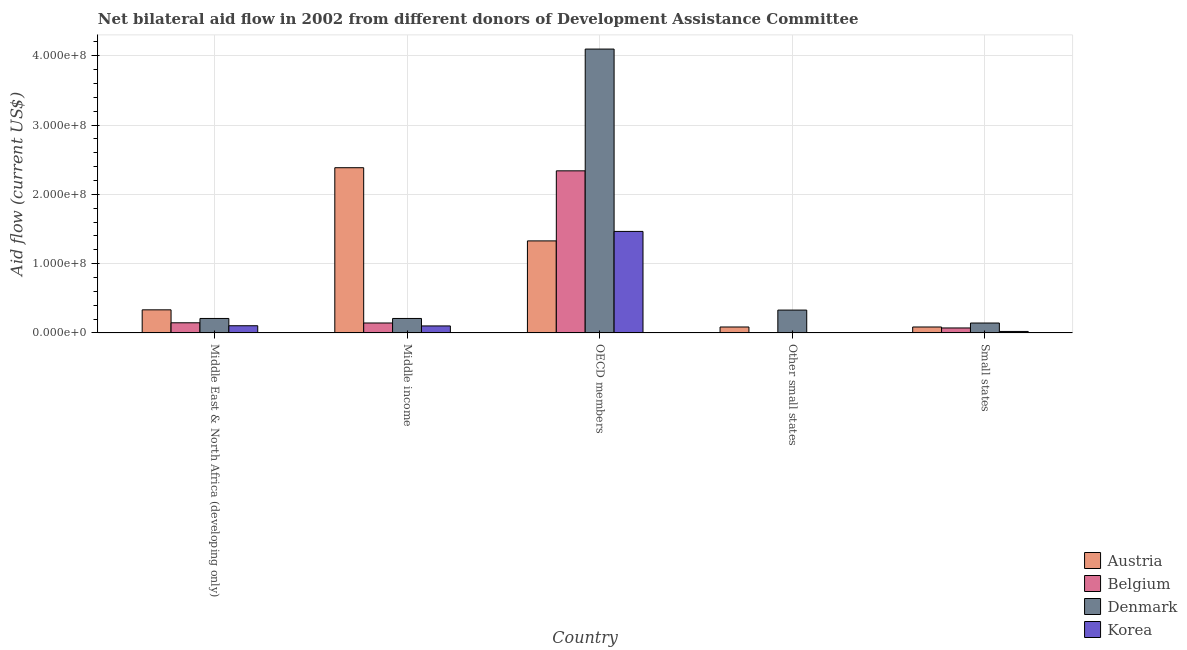How many different coloured bars are there?
Your response must be concise. 4. How many groups of bars are there?
Give a very brief answer. 5. How many bars are there on the 2nd tick from the right?
Make the answer very short. 2. What is the label of the 5th group of bars from the left?
Make the answer very short. Small states. In how many cases, is the number of bars for a given country not equal to the number of legend labels?
Ensure brevity in your answer.  1. What is the amount of aid given by austria in Middle income?
Your response must be concise. 2.38e+08. Across all countries, what is the maximum amount of aid given by austria?
Provide a short and direct response. 2.38e+08. What is the total amount of aid given by denmark in the graph?
Provide a short and direct response. 4.99e+08. What is the difference between the amount of aid given by korea in OECD members and that in Small states?
Provide a succinct answer. 1.44e+08. What is the difference between the amount of aid given by korea in OECD members and the amount of aid given by denmark in Other small states?
Provide a short and direct response. 1.14e+08. What is the average amount of aid given by denmark per country?
Offer a very short reply. 9.98e+07. What is the difference between the amount of aid given by korea and amount of aid given by belgium in Middle East & North Africa (developing only)?
Offer a very short reply. -4.26e+06. What is the ratio of the amount of aid given by denmark in Middle income to that in OECD members?
Ensure brevity in your answer.  0.05. Is the difference between the amount of aid given by denmark in Middle East & North Africa (developing only) and OECD members greater than the difference between the amount of aid given by korea in Middle East & North Africa (developing only) and OECD members?
Offer a very short reply. No. What is the difference between the highest and the second highest amount of aid given by austria?
Your answer should be very brief. 1.06e+08. What is the difference between the highest and the lowest amount of aid given by korea?
Your answer should be very brief. 1.47e+08. Is it the case that in every country, the sum of the amount of aid given by austria and amount of aid given by belgium is greater than the amount of aid given by denmark?
Provide a short and direct response. No. Are all the bars in the graph horizontal?
Keep it short and to the point. No. Does the graph contain grids?
Offer a very short reply. Yes. How are the legend labels stacked?
Ensure brevity in your answer.  Vertical. What is the title of the graph?
Your answer should be compact. Net bilateral aid flow in 2002 from different donors of Development Assistance Committee. What is the label or title of the Y-axis?
Ensure brevity in your answer.  Aid flow (current US$). What is the Aid flow (current US$) in Austria in Middle East & North Africa (developing only)?
Provide a succinct answer. 3.34e+07. What is the Aid flow (current US$) of Belgium in Middle East & North Africa (developing only)?
Provide a succinct answer. 1.46e+07. What is the Aid flow (current US$) in Denmark in Middle East & North Africa (developing only)?
Provide a short and direct response. 2.09e+07. What is the Aid flow (current US$) of Korea in Middle East & North Africa (developing only)?
Your response must be concise. 1.04e+07. What is the Aid flow (current US$) of Austria in Middle income?
Make the answer very short. 2.38e+08. What is the Aid flow (current US$) in Belgium in Middle income?
Provide a short and direct response. 1.44e+07. What is the Aid flow (current US$) of Denmark in Middle income?
Offer a very short reply. 2.09e+07. What is the Aid flow (current US$) of Korea in Middle income?
Provide a short and direct response. 1.01e+07. What is the Aid flow (current US$) of Austria in OECD members?
Make the answer very short. 1.33e+08. What is the Aid flow (current US$) of Belgium in OECD members?
Keep it short and to the point. 2.34e+08. What is the Aid flow (current US$) of Denmark in OECD members?
Keep it short and to the point. 4.10e+08. What is the Aid flow (current US$) in Korea in OECD members?
Provide a short and direct response. 1.47e+08. What is the Aid flow (current US$) in Austria in Other small states?
Your response must be concise. 8.59e+06. What is the Aid flow (current US$) of Denmark in Other small states?
Provide a short and direct response. 3.30e+07. What is the Aid flow (current US$) of Korea in Other small states?
Give a very brief answer. 0. What is the Aid flow (current US$) in Austria in Small states?
Your answer should be very brief. 8.59e+06. What is the Aid flow (current US$) in Belgium in Small states?
Offer a very short reply. 7.19e+06. What is the Aid flow (current US$) of Denmark in Small states?
Provide a succinct answer. 1.43e+07. What is the Aid flow (current US$) in Korea in Small states?
Keep it short and to the point. 2.16e+06. Across all countries, what is the maximum Aid flow (current US$) of Austria?
Your response must be concise. 2.38e+08. Across all countries, what is the maximum Aid flow (current US$) of Belgium?
Offer a very short reply. 2.34e+08. Across all countries, what is the maximum Aid flow (current US$) of Denmark?
Ensure brevity in your answer.  4.10e+08. Across all countries, what is the maximum Aid flow (current US$) in Korea?
Provide a succinct answer. 1.47e+08. Across all countries, what is the minimum Aid flow (current US$) in Austria?
Offer a very short reply. 8.59e+06. Across all countries, what is the minimum Aid flow (current US$) of Belgium?
Your answer should be compact. 0. Across all countries, what is the minimum Aid flow (current US$) in Denmark?
Provide a short and direct response. 1.43e+07. What is the total Aid flow (current US$) in Austria in the graph?
Ensure brevity in your answer.  4.22e+08. What is the total Aid flow (current US$) in Belgium in the graph?
Provide a succinct answer. 2.70e+08. What is the total Aid flow (current US$) of Denmark in the graph?
Offer a terse response. 4.99e+08. What is the total Aid flow (current US$) of Korea in the graph?
Your response must be concise. 1.69e+08. What is the difference between the Aid flow (current US$) of Austria in Middle East & North Africa (developing only) and that in Middle income?
Make the answer very short. -2.05e+08. What is the difference between the Aid flow (current US$) in Denmark in Middle East & North Africa (developing only) and that in Middle income?
Keep it short and to the point. 0. What is the difference between the Aid flow (current US$) of Austria in Middle East & North Africa (developing only) and that in OECD members?
Offer a terse response. -9.95e+07. What is the difference between the Aid flow (current US$) in Belgium in Middle East & North Africa (developing only) and that in OECD members?
Provide a succinct answer. -2.19e+08. What is the difference between the Aid flow (current US$) of Denmark in Middle East & North Africa (developing only) and that in OECD members?
Your answer should be compact. -3.89e+08. What is the difference between the Aid flow (current US$) in Korea in Middle East & North Africa (developing only) and that in OECD members?
Your answer should be compact. -1.36e+08. What is the difference between the Aid flow (current US$) in Austria in Middle East & North Africa (developing only) and that in Other small states?
Your answer should be compact. 2.48e+07. What is the difference between the Aid flow (current US$) in Denmark in Middle East & North Africa (developing only) and that in Other small states?
Give a very brief answer. -1.21e+07. What is the difference between the Aid flow (current US$) of Austria in Middle East & North Africa (developing only) and that in Small states?
Give a very brief answer. 2.48e+07. What is the difference between the Aid flow (current US$) of Belgium in Middle East & North Africa (developing only) and that in Small states?
Your answer should be compact. 7.46e+06. What is the difference between the Aid flow (current US$) of Denmark in Middle East & North Africa (developing only) and that in Small states?
Your answer should be compact. 6.59e+06. What is the difference between the Aid flow (current US$) of Korea in Middle East & North Africa (developing only) and that in Small states?
Your answer should be very brief. 8.23e+06. What is the difference between the Aid flow (current US$) of Austria in Middle income and that in OECD members?
Offer a terse response. 1.06e+08. What is the difference between the Aid flow (current US$) of Belgium in Middle income and that in OECD members?
Provide a succinct answer. -2.20e+08. What is the difference between the Aid flow (current US$) in Denmark in Middle income and that in OECD members?
Your response must be concise. -3.89e+08. What is the difference between the Aid flow (current US$) of Korea in Middle income and that in OECD members?
Offer a terse response. -1.36e+08. What is the difference between the Aid flow (current US$) of Austria in Middle income and that in Other small states?
Your response must be concise. 2.30e+08. What is the difference between the Aid flow (current US$) in Denmark in Middle income and that in Other small states?
Keep it short and to the point. -1.21e+07. What is the difference between the Aid flow (current US$) of Austria in Middle income and that in Small states?
Offer a terse response. 2.30e+08. What is the difference between the Aid flow (current US$) in Belgium in Middle income and that in Small states?
Make the answer very short. 7.16e+06. What is the difference between the Aid flow (current US$) in Denmark in Middle income and that in Small states?
Your response must be concise. 6.59e+06. What is the difference between the Aid flow (current US$) of Korea in Middle income and that in Small states?
Provide a short and direct response. 7.95e+06. What is the difference between the Aid flow (current US$) of Austria in OECD members and that in Other small states?
Make the answer very short. 1.24e+08. What is the difference between the Aid flow (current US$) of Denmark in OECD members and that in Other small states?
Give a very brief answer. 3.77e+08. What is the difference between the Aid flow (current US$) in Austria in OECD members and that in Small states?
Your answer should be compact. 1.24e+08. What is the difference between the Aid flow (current US$) of Belgium in OECD members and that in Small states?
Provide a short and direct response. 2.27e+08. What is the difference between the Aid flow (current US$) in Denmark in OECD members and that in Small states?
Make the answer very short. 3.95e+08. What is the difference between the Aid flow (current US$) of Korea in OECD members and that in Small states?
Ensure brevity in your answer.  1.44e+08. What is the difference between the Aid flow (current US$) of Austria in Other small states and that in Small states?
Your answer should be very brief. 0. What is the difference between the Aid flow (current US$) of Denmark in Other small states and that in Small states?
Keep it short and to the point. 1.87e+07. What is the difference between the Aid flow (current US$) in Austria in Middle East & North Africa (developing only) and the Aid flow (current US$) in Belgium in Middle income?
Your answer should be compact. 1.90e+07. What is the difference between the Aid flow (current US$) in Austria in Middle East & North Africa (developing only) and the Aid flow (current US$) in Denmark in Middle income?
Your answer should be compact. 1.24e+07. What is the difference between the Aid flow (current US$) of Austria in Middle East & North Africa (developing only) and the Aid flow (current US$) of Korea in Middle income?
Make the answer very short. 2.32e+07. What is the difference between the Aid flow (current US$) of Belgium in Middle East & North Africa (developing only) and the Aid flow (current US$) of Denmark in Middle income?
Make the answer very short. -6.26e+06. What is the difference between the Aid flow (current US$) of Belgium in Middle East & North Africa (developing only) and the Aid flow (current US$) of Korea in Middle income?
Offer a terse response. 4.54e+06. What is the difference between the Aid flow (current US$) of Denmark in Middle East & North Africa (developing only) and the Aid flow (current US$) of Korea in Middle income?
Your response must be concise. 1.08e+07. What is the difference between the Aid flow (current US$) of Austria in Middle East & North Africa (developing only) and the Aid flow (current US$) of Belgium in OECD members?
Offer a very short reply. -2.01e+08. What is the difference between the Aid flow (current US$) in Austria in Middle East & North Africa (developing only) and the Aid flow (current US$) in Denmark in OECD members?
Keep it short and to the point. -3.76e+08. What is the difference between the Aid flow (current US$) of Austria in Middle East & North Africa (developing only) and the Aid flow (current US$) of Korea in OECD members?
Ensure brevity in your answer.  -1.13e+08. What is the difference between the Aid flow (current US$) of Belgium in Middle East & North Africa (developing only) and the Aid flow (current US$) of Denmark in OECD members?
Make the answer very short. -3.95e+08. What is the difference between the Aid flow (current US$) in Belgium in Middle East & North Africa (developing only) and the Aid flow (current US$) in Korea in OECD members?
Make the answer very short. -1.32e+08. What is the difference between the Aid flow (current US$) of Denmark in Middle East & North Africa (developing only) and the Aid flow (current US$) of Korea in OECD members?
Your answer should be compact. -1.26e+08. What is the difference between the Aid flow (current US$) in Austria in Middle East & North Africa (developing only) and the Aid flow (current US$) in Denmark in Other small states?
Offer a very short reply. 3.70e+05. What is the difference between the Aid flow (current US$) in Belgium in Middle East & North Africa (developing only) and the Aid flow (current US$) in Denmark in Other small states?
Provide a succinct answer. -1.83e+07. What is the difference between the Aid flow (current US$) in Austria in Middle East & North Africa (developing only) and the Aid flow (current US$) in Belgium in Small states?
Give a very brief answer. 2.62e+07. What is the difference between the Aid flow (current US$) in Austria in Middle East & North Africa (developing only) and the Aid flow (current US$) in Denmark in Small states?
Make the answer very short. 1.90e+07. What is the difference between the Aid flow (current US$) in Austria in Middle East & North Africa (developing only) and the Aid flow (current US$) in Korea in Small states?
Ensure brevity in your answer.  3.12e+07. What is the difference between the Aid flow (current US$) of Belgium in Middle East & North Africa (developing only) and the Aid flow (current US$) of Korea in Small states?
Your answer should be compact. 1.25e+07. What is the difference between the Aid flow (current US$) in Denmark in Middle East & North Africa (developing only) and the Aid flow (current US$) in Korea in Small states?
Provide a short and direct response. 1.88e+07. What is the difference between the Aid flow (current US$) of Austria in Middle income and the Aid flow (current US$) of Belgium in OECD members?
Provide a short and direct response. 4.51e+06. What is the difference between the Aid flow (current US$) of Austria in Middle income and the Aid flow (current US$) of Denmark in OECD members?
Ensure brevity in your answer.  -1.71e+08. What is the difference between the Aid flow (current US$) of Austria in Middle income and the Aid flow (current US$) of Korea in OECD members?
Offer a terse response. 9.19e+07. What is the difference between the Aid flow (current US$) in Belgium in Middle income and the Aid flow (current US$) in Denmark in OECD members?
Ensure brevity in your answer.  -3.95e+08. What is the difference between the Aid flow (current US$) of Belgium in Middle income and the Aid flow (current US$) of Korea in OECD members?
Provide a short and direct response. -1.32e+08. What is the difference between the Aid flow (current US$) of Denmark in Middle income and the Aid flow (current US$) of Korea in OECD members?
Give a very brief answer. -1.26e+08. What is the difference between the Aid flow (current US$) of Austria in Middle income and the Aid flow (current US$) of Denmark in Other small states?
Your response must be concise. 2.06e+08. What is the difference between the Aid flow (current US$) in Belgium in Middle income and the Aid flow (current US$) in Denmark in Other small states?
Provide a short and direct response. -1.86e+07. What is the difference between the Aid flow (current US$) of Austria in Middle income and the Aid flow (current US$) of Belgium in Small states?
Provide a short and direct response. 2.31e+08. What is the difference between the Aid flow (current US$) in Austria in Middle income and the Aid flow (current US$) in Denmark in Small states?
Offer a terse response. 2.24e+08. What is the difference between the Aid flow (current US$) of Austria in Middle income and the Aid flow (current US$) of Korea in Small states?
Offer a very short reply. 2.36e+08. What is the difference between the Aid flow (current US$) in Belgium in Middle income and the Aid flow (current US$) in Korea in Small states?
Give a very brief answer. 1.22e+07. What is the difference between the Aid flow (current US$) of Denmark in Middle income and the Aid flow (current US$) of Korea in Small states?
Your response must be concise. 1.88e+07. What is the difference between the Aid flow (current US$) in Austria in OECD members and the Aid flow (current US$) in Denmark in Other small states?
Your answer should be very brief. 9.99e+07. What is the difference between the Aid flow (current US$) of Belgium in OECD members and the Aid flow (current US$) of Denmark in Other small states?
Make the answer very short. 2.01e+08. What is the difference between the Aid flow (current US$) in Austria in OECD members and the Aid flow (current US$) in Belgium in Small states?
Give a very brief answer. 1.26e+08. What is the difference between the Aid flow (current US$) of Austria in OECD members and the Aid flow (current US$) of Denmark in Small states?
Give a very brief answer. 1.19e+08. What is the difference between the Aid flow (current US$) in Austria in OECD members and the Aid flow (current US$) in Korea in Small states?
Your answer should be compact. 1.31e+08. What is the difference between the Aid flow (current US$) of Belgium in OECD members and the Aid flow (current US$) of Denmark in Small states?
Keep it short and to the point. 2.20e+08. What is the difference between the Aid flow (current US$) in Belgium in OECD members and the Aid flow (current US$) in Korea in Small states?
Make the answer very short. 2.32e+08. What is the difference between the Aid flow (current US$) in Denmark in OECD members and the Aid flow (current US$) in Korea in Small states?
Make the answer very short. 4.08e+08. What is the difference between the Aid flow (current US$) of Austria in Other small states and the Aid flow (current US$) of Belgium in Small states?
Your answer should be compact. 1.40e+06. What is the difference between the Aid flow (current US$) of Austria in Other small states and the Aid flow (current US$) of Denmark in Small states?
Provide a succinct answer. -5.73e+06. What is the difference between the Aid flow (current US$) in Austria in Other small states and the Aid flow (current US$) in Korea in Small states?
Give a very brief answer. 6.43e+06. What is the difference between the Aid flow (current US$) in Denmark in Other small states and the Aid flow (current US$) in Korea in Small states?
Offer a very short reply. 3.08e+07. What is the average Aid flow (current US$) of Austria per country?
Your answer should be very brief. 8.44e+07. What is the average Aid flow (current US$) in Belgium per country?
Give a very brief answer. 5.40e+07. What is the average Aid flow (current US$) in Denmark per country?
Provide a short and direct response. 9.98e+07. What is the average Aid flow (current US$) of Korea per country?
Offer a terse response. 3.38e+07. What is the difference between the Aid flow (current US$) in Austria and Aid flow (current US$) in Belgium in Middle East & North Africa (developing only)?
Give a very brief answer. 1.87e+07. What is the difference between the Aid flow (current US$) of Austria and Aid flow (current US$) of Denmark in Middle East & North Africa (developing only)?
Make the answer very short. 1.24e+07. What is the difference between the Aid flow (current US$) of Austria and Aid flow (current US$) of Korea in Middle East & North Africa (developing only)?
Offer a very short reply. 2.30e+07. What is the difference between the Aid flow (current US$) in Belgium and Aid flow (current US$) in Denmark in Middle East & North Africa (developing only)?
Give a very brief answer. -6.26e+06. What is the difference between the Aid flow (current US$) in Belgium and Aid flow (current US$) in Korea in Middle East & North Africa (developing only)?
Your answer should be compact. 4.26e+06. What is the difference between the Aid flow (current US$) of Denmark and Aid flow (current US$) of Korea in Middle East & North Africa (developing only)?
Provide a short and direct response. 1.05e+07. What is the difference between the Aid flow (current US$) of Austria and Aid flow (current US$) of Belgium in Middle income?
Ensure brevity in your answer.  2.24e+08. What is the difference between the Aid flow (current US$) of Austria and Aid flow (current US$) of Denmark in Middle income?
Your answer should be compact. 2.18e+08. What is the difference between the Aid flow (current US$) of Austria and Aid flow (current US$) of Korea in Middle income?
Your answer should be very brief. 2.28e+08. What is the difference between the Aid flow (current US$) in Belgium and Aid flow (current US$) in Denmark in Middle income?
Your answer should be compact. -6.56e+06. What is the difference between the Aid flow (current US$) of Belgium and Aid flow (current US$) of Korea in Middle income?
Keep it short and to the point. 4.24e+06. What is the difference between the Aid flow (current US$) of Denmark and Aid flow (current US$) of Korea in Middle income?
Your answer should be very brief. 1.08e+07. What is the difference between the Aid flow (current US$) of Austria and Aid flow (current US$) of Belgium in OECD members?
Offer a terse response. -1.01e+08. What is the difference between the Aid flow (current US$) of Austria and Aid flow (current US$) of Denmark in OECD members?
Your answer should be compact. -2.77e+08. What is the difference between the Aid flow (current US$) of Austria and Aid flow (current US$) of Korea in OECD members?
Your answer should be very brief. -1.37e+07. What is the difference between the Aid flow (current US$) in Belgium and Aid flow (current US$) in Denmark in OECD members?
Give a very brief answer. -1.76e+08. What is the difference between the Aid flow (current US$) of Belgium and Aid flow (current US$) of Korea in OECD members?
Provide a short and direct response. 8.74e+07. What is the difference between the Aid flow (current US$) in Denmark and Aid flow (current US$) in Korea in OECD members?
Keep it short and to the point. 2.63e+08. What is the difference between the Aid flow (current US$) of Austria and Aid flow (current US$) of Denmark in Other small states?
Ensure brevity in your answer.  -2.44e+07. What is the difference between the Aid flow (current US$) of Austria and Aid flow (current US$) of Belgium in Small states?
Provide a short and direct response. 1.40e+06. What is the difference between the Aid flow (current US$) of Austria and Aid flow (current US$) of Denmark in Small states?
Provide a short and direct response. -5.73e+06. What is the difference between the Aid flow (current US$) of Austria and Aid flow (current US$) of Korea in Small states?
Provide a succinct answer. 6.43e+06. What is the difference between the Aid flow (current US$) of Belgium and Aid flow (current US$) of Denmark in Small states?
Offer a very short reply. -7.13e+06. What is the difference between the Aid flow (current US$) of Belgium and Aid flow (current US$) of Korea in Small states?
Keep it short and to the point. 5.03e+06. What is the difference between the Aid flow (current US$) of Denmark and Aid flow (current US$) of Korea in Small states?
Provide a short and direct response. 1.22e+07. What is the ratio of the Aid flow (current US$) of Austria in Middle East & North Africa (developing only) to that in Middle income?
Provide a short and direct response. 0.14. What is the ratio of the Aid flow (current US$) of Belgium in Middle East & North Africa (developing only) to that in Middle income?
Provide a succinct answer. 1.02. What is the ratio of the Aid flow (current US$) of Korea in Middle East & North Africa (developing only) to that in Middle income?
Ensure brevity in your answer.  1.03. What is the ratio of the Aid flow (current US$) of Austria in Middle East & North Africa (developing only) to that in OECD members?
Make the answer very short. 0.25. What is the ratio of the Aid flow (current US$) in Belgium in Middle East & North Africa (developing only) to that in OECD members?
Provide a short and direct response. 0.06. What is the ratio of the Aid flow (current US$) of Denmark in Middle East & North Africa (developing only) to that in OECD members?
Ensure brevity in your answer.  0.05. What is the ratio of the Aid flow (current US$) in Korea in Middle East & North Africa (developing only) to that in OECD members?
Provide a short and direct response. 0.07. What is the ratio of the Aid flow (current US$) of Austria in Middle East & North Africa (developing only) to that in Other small states?
Give a very brief answer. 3.88. What is the ratio of the Aid flow (current US$) of Denmark in Middle East & North Africa (developing only) to that in Other small states?
Provide a short and direct response. 0.63. What is the ratio of the Aid flow (current US$) in Austria in Middle East & North Africa (developing only) to that in Small states?
Provide a short and direct response. 3.88. What is the ratio of the Aid flow (current US$) of Belgium in Middle East & North Africa (developing only) to that in Small states?
Your answer should be compact. 2.04. What is the ratio of the Aid flow (current US$) of Denmark in Middle East & North Africa (developing only) to that in Small states?
Make the answer very short. 1.46. What is the ratio of the Aid flow (current US$) in Korea in Middle East & North Africa (developing only) to that in Small states?
Ensure brevity in your answer.  4.81. What is the ratio of the Aid flow (current US$) in Austria in Middle income to that in OECD members?
Ensure brevity in your answer.  1.8. What is the ratio of the Aid flow (current US$) of Belgium in Middle income to that in OECD members?
Provide a short and direct response. 0.06. What is the ratio of the Aid flow (current US$) of Denmark in Middle income to that in OECD members?
Keep it short and to the point. 0.05. What is the ratio of the Aid flow (current US$) of Korea in Middle income to that in OECD members?
Your answer should be compact. 0.07. What is the ratio of the Aid flow (current US$) of Austria in Middle income to that in Other small states?
Provide a short and direct response. 27.76. What is the ratio of the Aid flow (current US$) of Denmark in Middle income to that in Other small states?
Ensure brevity in your answer.  0.63. What is the ratio of the Aid flow (current US$) of Austria in Middle income to that in Small states?
Your answer should be very brief. 27.76. What is the ratio of the Aid flow (current US$) in Belgium in Middle income to that in Small states?
Provide a short and direct response. 2. What is the ratio of the Aid flow (current US$) in Denmark in Middle income to that in Small states?
Provide a short and direct response. 1.46. What is the ratio of the Aid flow (current US$) in Korea in Middle income to that in Small states?
Keep it short and to the point. 4.68. What is the ratio of the Aid flow (current US$) of Austria in OECD members to that in Other small states?
Your response must be concise. 15.47. What is the ratio of the Aid flow (current US$) of Denmark in OECD members to that in Other small states?
Keep it short and to the point. 12.42. What is the ratio of the Aid flow (current US$) in Austria in OECD members to that in Small states?
Offer a very short reply. 15.47. What is the ratio of the Aid flow (current US$) of Belgium in OECD members to that in Small states?
Make the answer very short. 32.54. What is the ratio of the Aid flow (current US$) in Denmark in OECD members to that in Small states?
Provide a short and direct response. 28.61. What is the ratio of the Aid flow (current US$) in Korea in OECD members to that in Small states?
Your answer should be compact. 67.85. What is the ratio of the Aid flow (current US$) in Austria in Other small states to that in Small states?
Provide a succinct answer. 1. What is the ratio of the Aid flow (current US$) of Denmark in Other small states to that in Small states?
Provide a short and direct response. 2.3. What is the difference between the highest and the second highest Aid flow (current US$) in Austria?
Offer a very short reply. 1.06e+08. What is the difference between the highest and the second highest Aid flow (current US$) of Belgium?
Ensure brevity in your answer.  2.19e+08. What is the difference between the highest and the second highest Aid flow (current US$) of Denmark?
Offer a terse response. 3.77e+08. What is the difference between the highest and the second highest Aid flow (current US$) in Korea?
Ensure brevity in your answer.  1.36e+08. What is the difference between the highest and the lowest Aid flow (current US$) in Austria?
Offer a very short reply. 2.30e+08. What is the difference between the highest and the lowest Aid flow (current US$) of Belgium?
Make the answer very short. 2.34e+08. What is the difference between the highest and the lowest Aid flow (current US$) of Denmark?
Give a very brief answer. 3.95e+08. What is the difference between the highest and the lowest Aid flow (current US$) in Korea?
Offer a very short reply. 1.47e+08. 